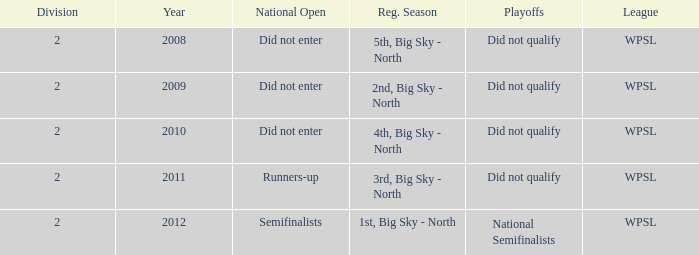What is the lowest division number? 2.0. 